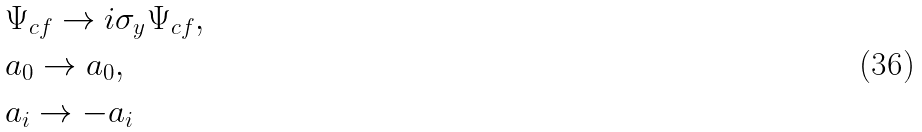<formula> <loc_0><loc_0><loc_500><loc_500>& \Psi _ { c f } \rightarrow i \sigma _ { y } \Psi _ { c f } , \\ & a _ { 0 } \rightarrow a _ { 0 } , \\ & a _ { i } \rightarrow - a _ { i }</formula> 